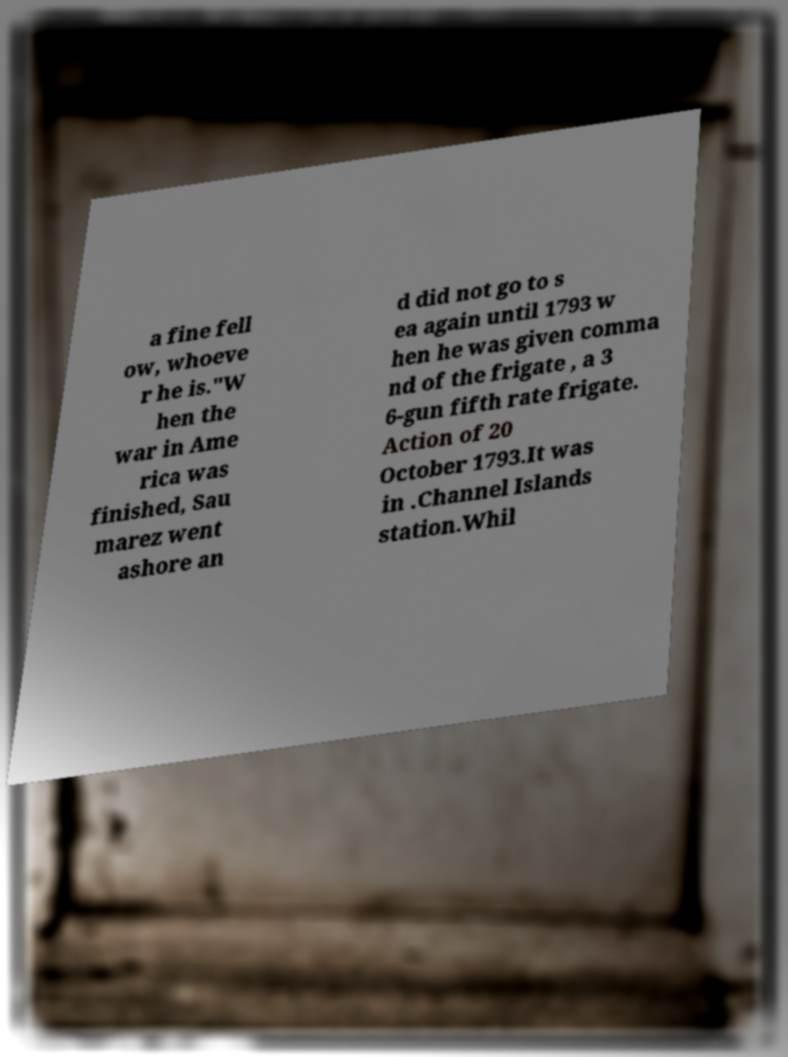Can you read and provide the text displayed in the image?This photo seems to have some interesting text. Can you extract and type it out for me? a fine fell ow, whoeve r he is."W hen the war in Ame rica was finished, Sau marez went ashore an d did not go to s ea again until 1793 w hen he was given comma nd of the frigate , a 3 6-gun fifth rate frigate. Action of 20 October 1793.It was in .Channel Islands station.Whil 